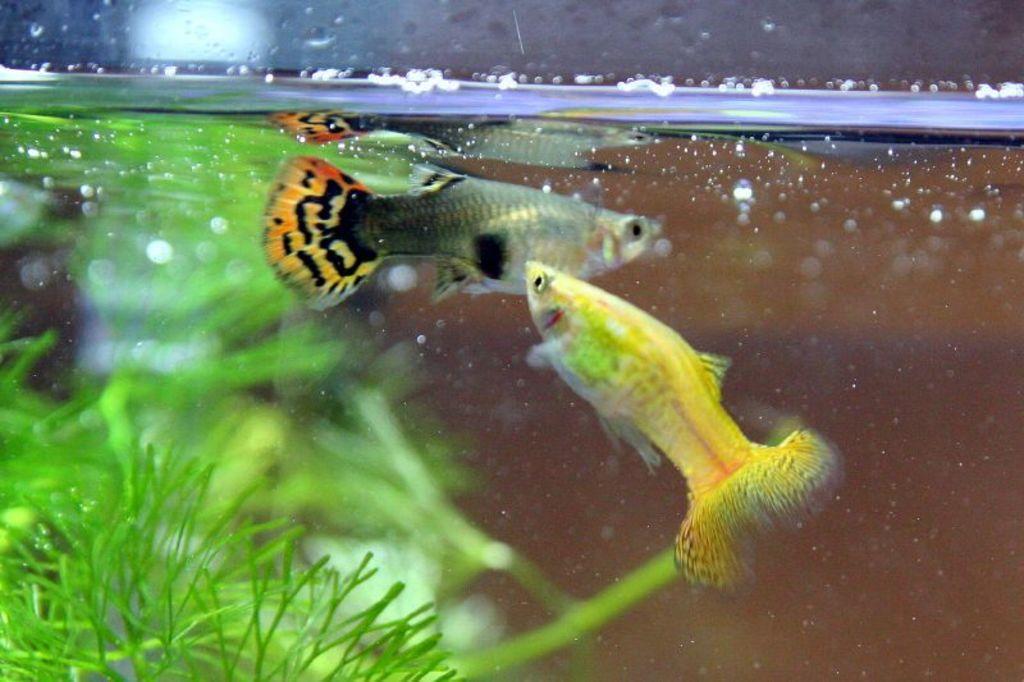Describe this image in one or two sentences. In this image I can see there are two beautiful fishes in the water in an aquarium. On the left side there are green leaves. 